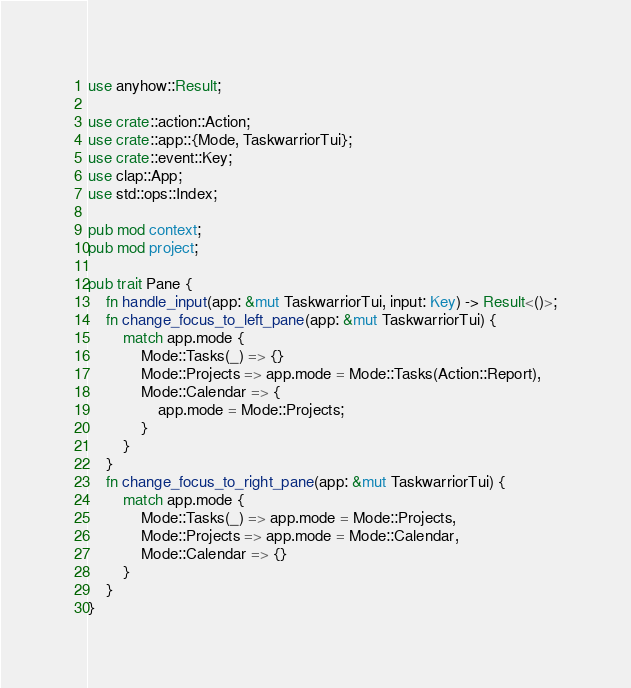<code> <loc_0><loc_0><loc_500><loc_500><_Rust_>use anyhow::Result;

use crate::action::Action;
use crate::app::{Mode, TaskwarriorTui};
use crate::event::Key;
use clap::App;
use std::ops::Index;

pub mod context;
pub mod project;

pub trait Pane {
    fn handle_input(app: &mut TaskwarriorTui, input: Key) -> Result<()>;
    fn change_focus_to_left_pane(app: &mut TaskwarriorTui) {
        match app.mode {
            Mode::Tasks(_) => {}
            Mode::Projects => app.mode = Mode::Tasks(Action::Report),
            Mode::Calendar => {
                app.mode = Mode::Projects;
            }
        }
    }
    fn change_focus_to_right_pane(app: &mut TaskwarriorTui) {
        match app.mode {
            Mode::Tasks(_) => app.mode = Mode::Projects,
            Mode::Projects => app.mode = Mode::Calendar,
            Mode::Calendar => {}
        }
    }
}
</code> 